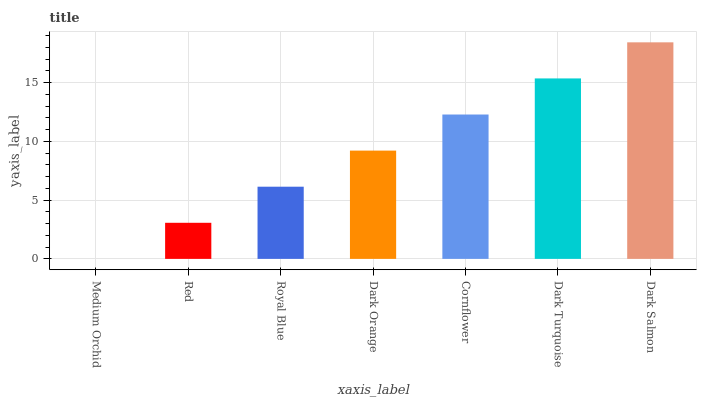Is Medium Orchid the minimum?
Answer yes or no. Yes. Is Dark Salmon the maximum?
Answer yes or no. Yes. Is Red the minimum?
Answer yes or no. No. Is Red the maximum?
Answer yes or no. No. Is Red greater than Medium Orchid?
Answer yes or no. Yes. Is Medium Orchid less than Red?
Answer yes or no. Yes. Is Medium Orchid greater than Red?
Answer yes or no. No. Is Red less than Medium Orchid?
Answer yes or no. No. Is Dark Orange the high median?
Answer yes or no. Yes. Is Dark Orange the low median?
Answer yes or no. Yes. Is Dark Turquoise the high median?
Answer yes or no. No. Is Dark Turquoise the low median?
Answer yes or no. No. 